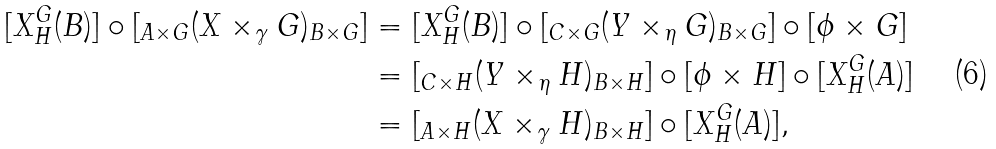<formula> <loc_0><loc_0><loc_500><loc_500>[ X _ { H } ^ { G } ( B ) ] \circ [ _ { A \times G } ( X \times _ { \gamma } G ) _ { B \times G } ] & = [ X _ { H } ^ { G } ( B ) ] \circ [ _ { C \times G } ( Y \times _ { \eta } G ) _ { B \times G } ] \circ [ \phi \times G ] \\ & = [ _ { C \times H } ( Y \times _ { \eta } H ) _ { B \times H } ] \circ [ \phi \times H ] \circ [ X _ { H } ^ { G } ( A ) ] \\ & = [ _ { A \times H } ( X \times _ { \gamma } H ) _ { B \times H } ] \circ [ X _ { H } ^ { G } ( A ) ] ,</formula> 